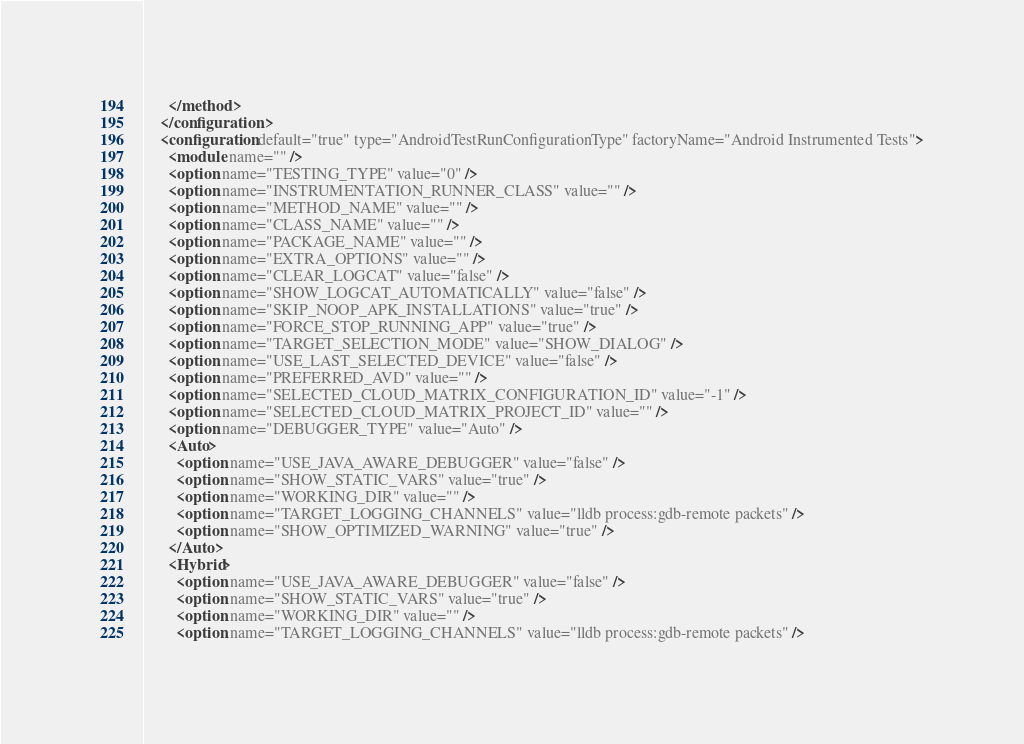Convert code to text. <code><loc_0><loc_0><loc_500><loc_500><_XML_>      </method>
    </configuration>
    <configuration default="true" type="AndroidTestRunConfigurationType" factoryName="Android Instrumented Tests">
      <module name="" />
      <option name="TESTING_TYPE" value="0" />
      <option name="INSTRUMENTATION_RUNNER_CLASS" value="" />
      <option name="METHOD_NAME" value="" />
      <option name="CLASS_NAME" value="" />
      <option name="PACKAGE_NAME" value="" />
      <option name="EXTRA_OPTIONS" value="" />
      <option name="CLEAR_LOGCAT" value="false" />
      <option name="SHOW_LOGCAT_AUTOMATICALLY" value="false" />
      <option name="SKIP_NOOP_APK_INSTALLATIONS" value="true" />
      <option name="FORCE_STOP_RUNNING_APP" value="true" />
      <option name="TARGET_SELECTION_MODE" value="SHOW_DIALOG" />
      <option name="USE_LAST_SELECTED_DEVICE" value="false" />
      <option name="PREFERRED_AVD" value="" />
      <option name="SELECTED_CLOUD_MATRIX_CONFIGURATION_ID" value="-1" />
      <option name="SELECTED_CLOUD_MATRIX_PROJECT_ID" value="" />
      <option name="DEBUGGER_TYPE" value="Auto" />
      <Auto>
        <option name="USE_JAVA_AWARE_DEBUGGER" value="false" />
        <option name="SHOW_STATIC_VARS" value="true" />
        <option name="WORKING_DIR" value="" />
        <option name="TARGET_LOGGING_CHANNELS" value="lldb process:gdb-remote packets" />
        <option name="SHOW_OPTIMIZED_WARNING" value="true" />
      </Auto>
      <Hybrid>
        <option name="USE_JAVA_AWARE_DEBUGGER" value="false" />
        <option name="SHOW_STATIC_VARS" value="true" />
        <option name="WORKING_DIR" value="" />
        <option name="TARGET_LOGGING_CHANNELS" value="lldb process:gdb-remote packets" /></code> 